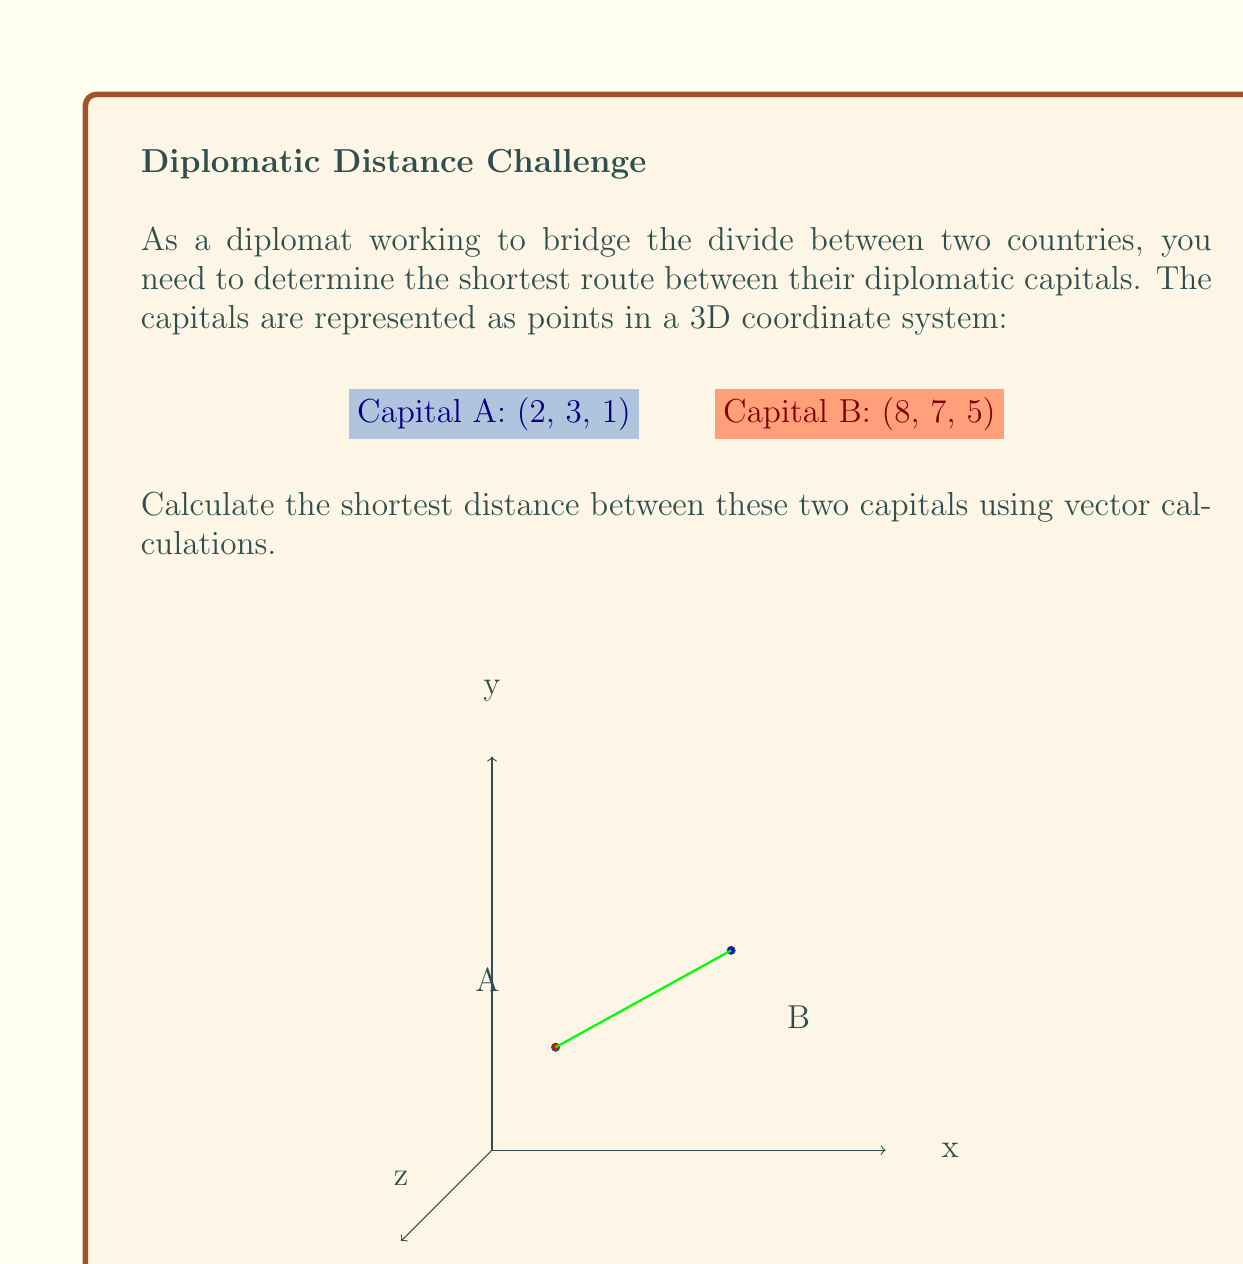Can you answer this question? To find the shortest distance between two points in 3D space, we can use the distance formula derived from vector calculations:

1) First, let's define the vector $\vec{v}$ from point A to point B:
   $\vec{v} = B - A = (8-2, 7-3, 5-1) = (6, 4, 4)$

2) The magnitude of this vector will give us the shortest distance. We can calculate this using the Euclidean norm:

   $$d = \|\vec{v}\| = \sqrt{v_x^2 + v_y^2 + v_z^2}$$

3) Substituting our values:
   $$d = \sqrt{6^2 + 4^2 + 4^2}$$

4) Simplify:
   $$d = \sqrt{36 + 16 + 16} = \sqrt{68}$$

5) Simplify the square root:
   $$d = 2\sqrt{17}$$

Therefore, the shortest distance between the two diplomatic capitals is $2\sqrt{17}$ units.
Answer: $2\sqrt{17}$ units 